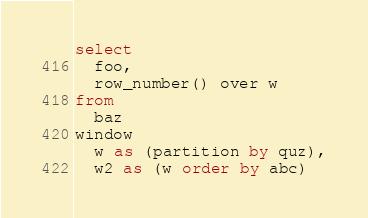Convert code to text. <code><loc_0><loc_0><loc_500><loc_500><_SQL_>select
  foo,
  row_number() over w
from
  baz
window
  w as (partition by quz),
  w2 as (w order by abc)
</code> 